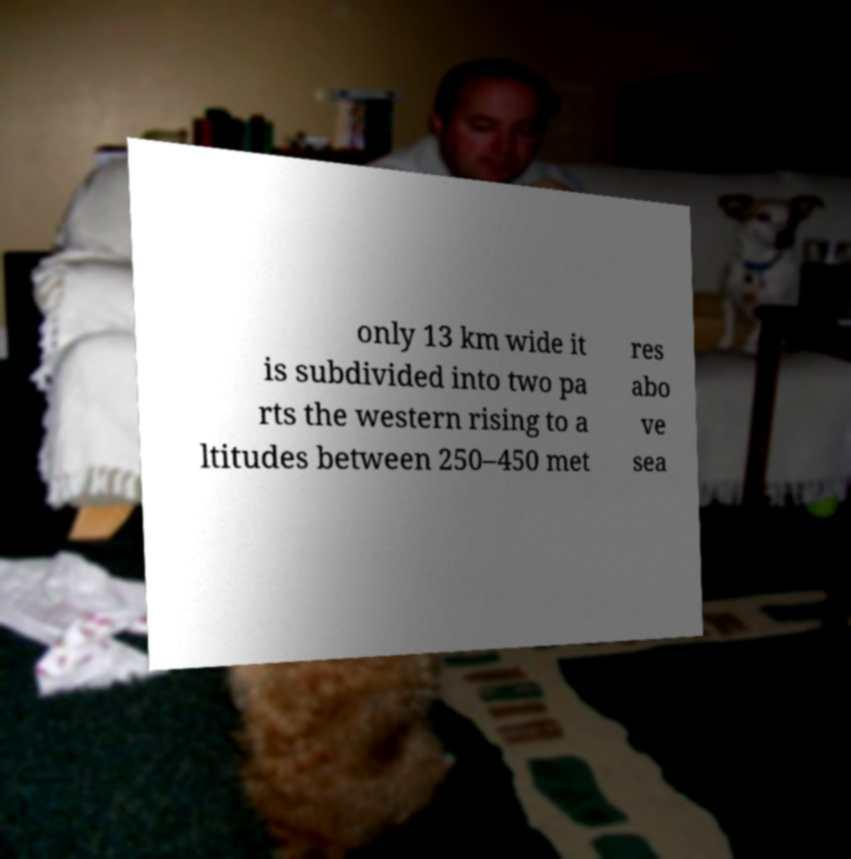Please identify and transcribe the text found in this image. only 13 km wide it is subdivided into two pa rts the western rising to a ltitudes between 250–450 met res abo ve sea 